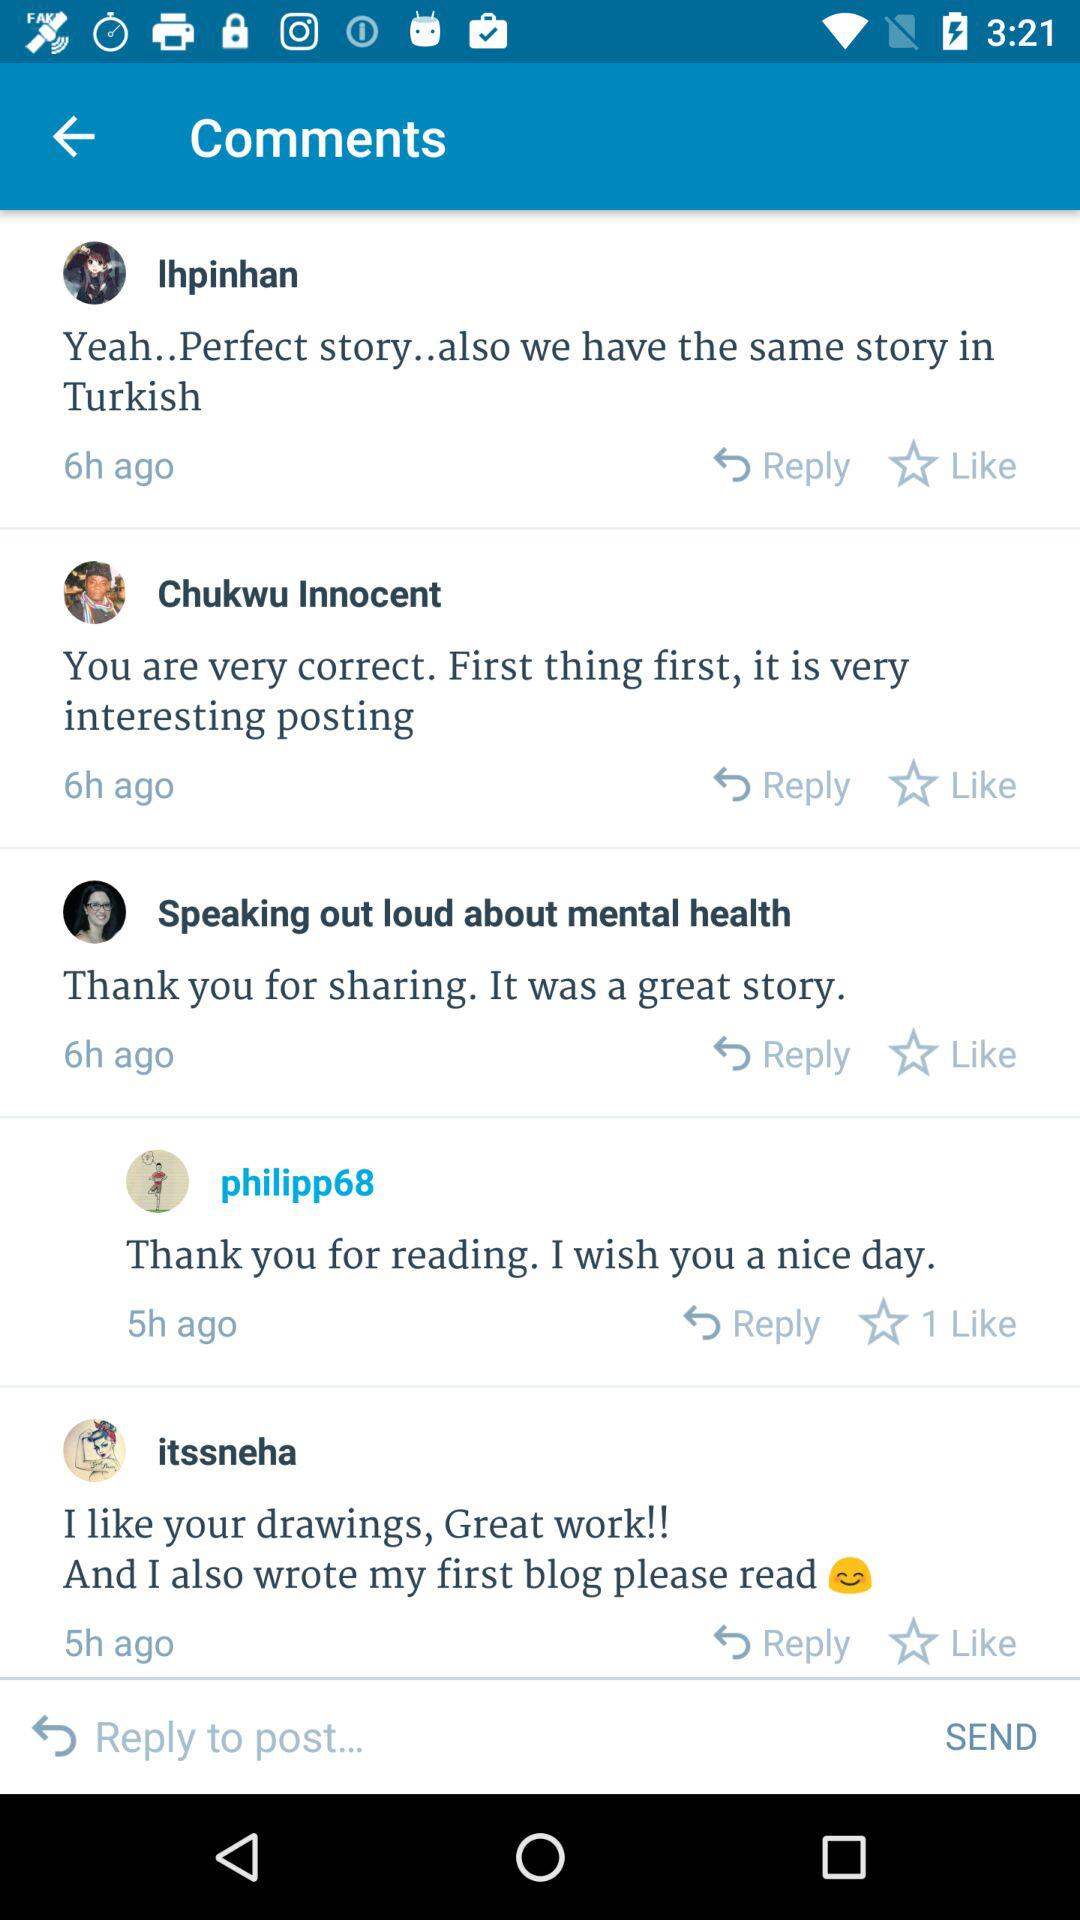How many comments are there?
Answer the question using a single word or phrase. 4 